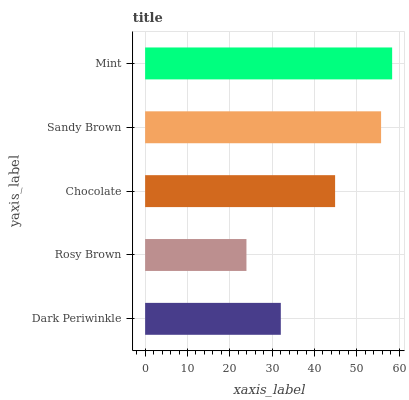Is Rosy Brown the minimum?
Answer yes or no. Yes. Is Mint the maximum?
Answer yes or no. Yes. Is Chocolate the minimum?
Answer yes or no. No. Is Chocolate the maximum?
Answer yes or no. No. Is Chocolate greater than Rosy Brown?
Answer yes or no. Yes. Is Rosy Brown less than Chocolate?
Answer yes or no. Yes. Is Rosy Brown greater than Chocolate?
Answer yes or no. No. Is Chocolate less than Rosy Brown?
Answer yes or no. No. Is Chocolate the high median?
Answer yes or no. Yes. Is Chocolate the low median?
Answer yes or no. Yes. Is Dark Periwinkle the high median?
Answer yes or no. No. Is Rosy Brown the low median?
Answer yes or no. No. 